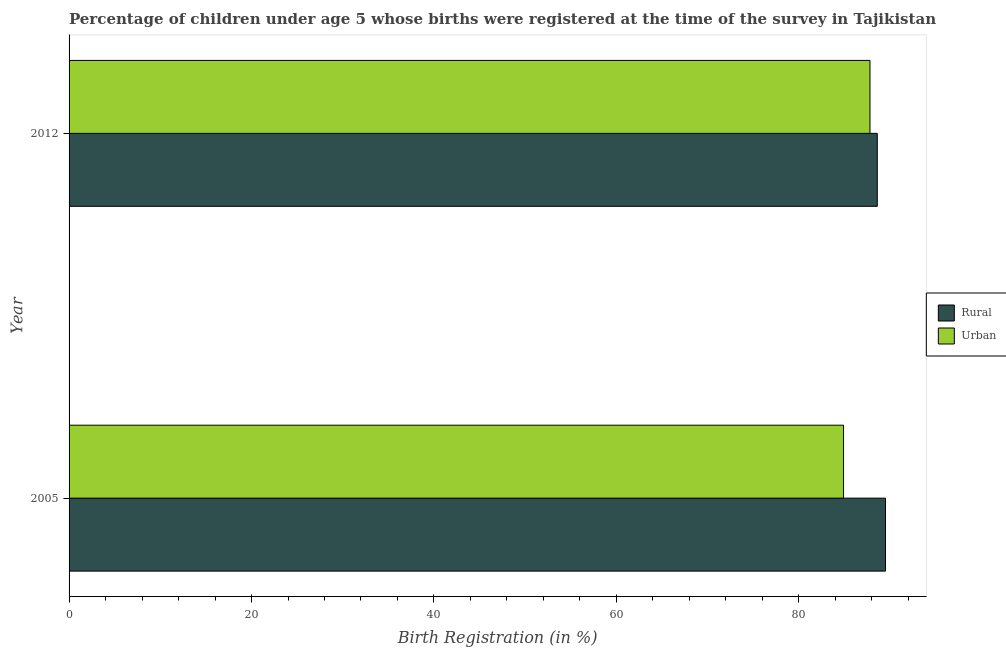How many different coloured bars are there?
Provide a succinct answer. 2. How many bars are there on the 1st tick from the top?
Offer a terse response. 2. What is the urban birth registration in 2005?
Offer a terse response. 84.9. Across all years, what is the maximum rural birth registration?
Give a very brief answer. 89.5. Across all years, what is the minimum rural birth registration?
Provide a short and direct response. 88.6. What is the total rural birth registration in the graph?
Make the answer very short. 178.1. What is the difference between the urban birth registration in 2005 and that in 2012?
Ensure brevity in your answer.  -2.9. What is the difference between the urban birth registration in 2005 and the rural birth registration in 2012?
Offer a terse response. -3.7. What is the average rural birth registration per year?
Provide a succinct answer. 89.05. In the year 2012, what is the difference between the urban birth registration and rural birth registration?
Offer a terse response. -0.8. What is the ratio of the urban birth registration in 2005 to that in 2012?
Keep it short and to the point. 0.97. Is the urban birth registration in 2005 less than that in 2012?
Your answer should be very brief. Yes. Is the difference between the urban birth registration in 2005 and 2012 greater than the difference between the rural birth registration in 2005 and 2012?
Your answer should be compact. No. What does the 2nd bar from the top in 2005 represents?
Your answer should be very brief. Rural. What does the 1st bar from the bottom in 2005 represents?
Provide a short and direct response. Rural. Are the values on the major ticks of X-axis written in scientific E-notation?
Provide a short and direct response. No. Does the graph contain any zero values?
Provide a short and direct response. No. Does the graph contain grids?
Make the answer very short. No. Where does the legend appear in the graph?
Offer a very short reply. Center right. How are the legend labels stacked?
Provide a succinct answer. Vertical. What is the title of the graph?
Make the answer very short. Percentage of children under age 5 whose births were registered at the time of the survey in Tajikistan. What is the label or title of the X-axis?
Offer a very short reply. Birth Registration (in %). What is the label or title of the Y-axis?
Your response must be concise. Year. What is the Birth Registration (in %) in Rural in 2005?
Your answer should be compact. 89.5. What is the Birth Registration (in %) in Urban in 2005?
Provide a succinct answer. 84.9. What is the Birth Registration (in %) of Rural in 2012?
Offer a terse response. 88.6. What is the Birth Registration (in %) in Urban in 2012?
Keep it short and to the point. 87.8. Across all years, what is the maximum Birth Registration (in %) in Rural?
Your answer should be compact. 89.5. Across all years, what is the maximum Birth Registration (in %) of Urban?
Your response must be concise. 87.8. Across all years, what is the minimum Birth Registration (in %) in Rural?
Offer a terse response. 88.6. Across all years, what is the minimum Birth Registration (in %) in Urban?
Your response must be concise. 84.9. What is the total Birth Registration (in %) of Rural in the graph?
Your answer should be compact. 178.1. What is the total Birth Registration (in %) in Urban in the graph?
Your answer should be compact. 172.7. What is the difference between the Birth Registration (in %) of Urban in 2005 and that in 2012?
Make the answer very short. -2.9. What is the difference between the Birth Registration (in %) in Rural in 2005 and the Birth Registration (in %) in Urban in 2012?
Your answer should be very brief. 1.7. What is the average Birth Registration (in %) in Rural per year?
Provide a short and direct response. 89.05. What is the average Birth Registration (in %) in Urban per year?
Ensure brevity in your answer.  86.35. In the year 2005, what is the difference between the Birth Registration (in %) in Rural and Birth Registration (in %) in Urban?
Provide a short and direct response. 4.6. What is the ratio of the Birth Registration (in %) of Rural in 2005 to that in 2012?
Make the answer very short. 1.01. What is the ratio of the Birth Registration (in %) in Urban in 2005 to that in 2012?
Provide a short and direct response. 0.97. What is the difference between the highest and the second highest Birth Registration (in %) of Rural?
Keep it short and to the point. 0.9. What is the difference between the highest and the second highest Birth Registration (in %) in Urban?
Offer a terse response. 2.9. 